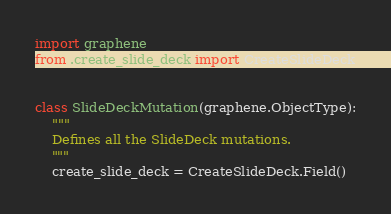<code> <loc_0><loc_0><loc_500><loc_500><_Python_>import graphene
from .create_slide_deck import CreateSlideDeck


class SlideDeckMutation(graphene.ObjectType):
    """
    Defines all the SlideDeck mutations.
    """
    create_slide_deck = CreateSlideDeck.Field()
</code> 